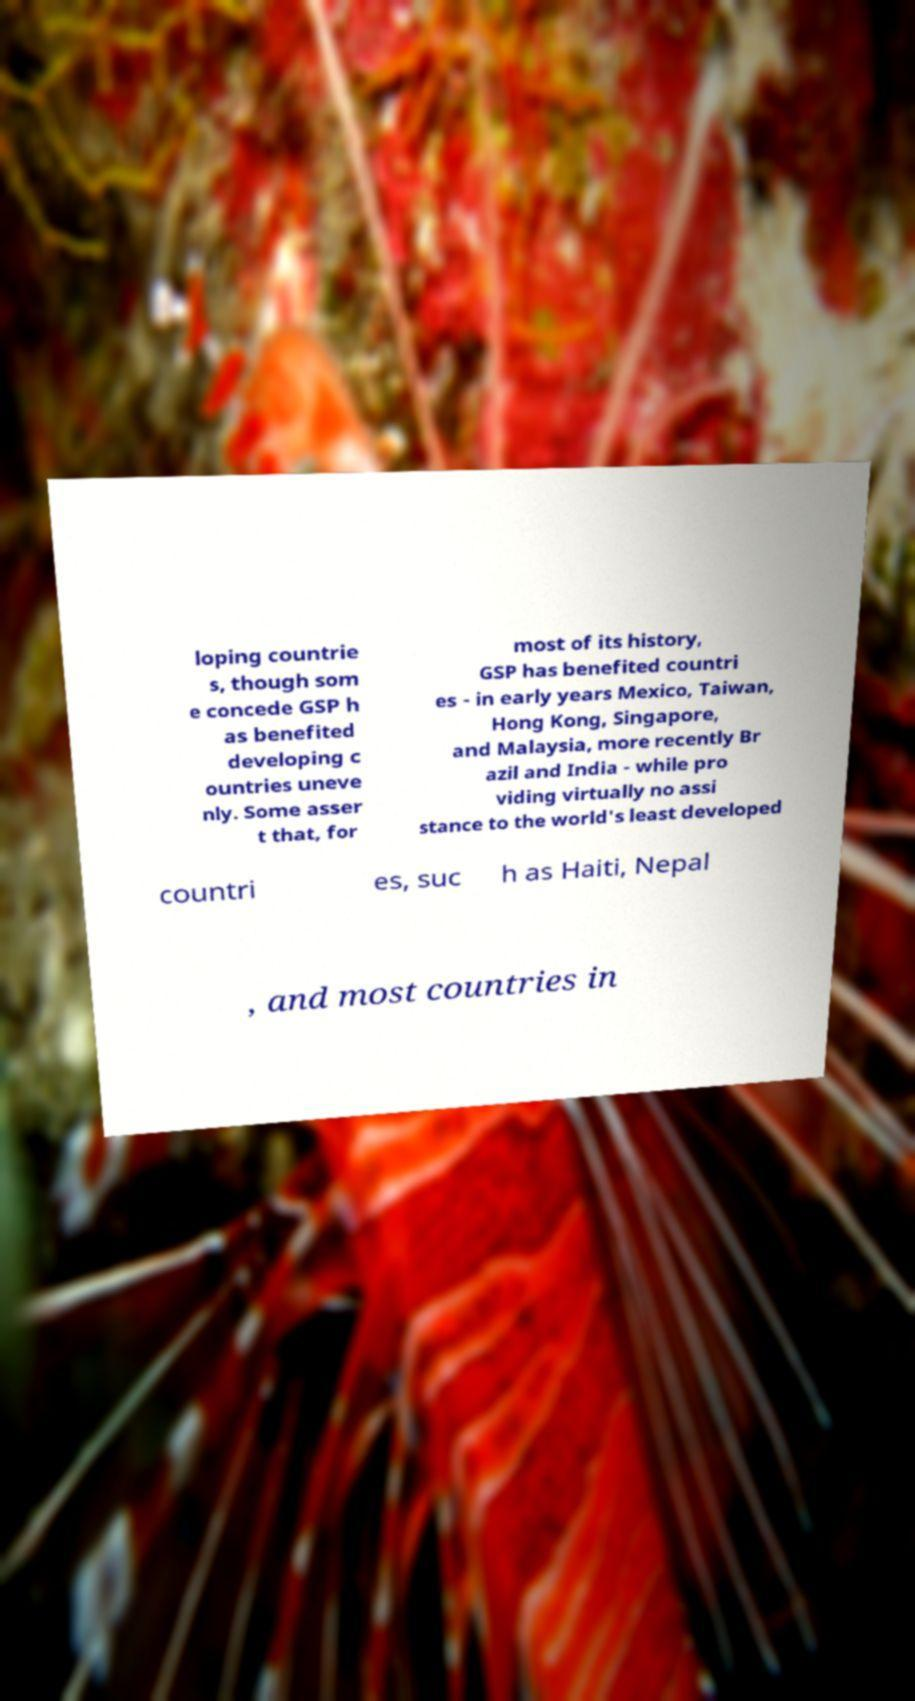Could you assist in decoding the text presented in this image and type it out clearly? loping countrie s, though som e concede GSP h as benefited developing c ountries uneve nly. Some asser t that, for most of its history, GSP has benefited countri es - in early years Mexico, Taiwan, Hong Kong, Singapore, and Malaysia, more recently Br azil and India - while pro viding virtually no assi stance to the world's least developed countri es, suc h as Haiti, Nepal , and most countries in 